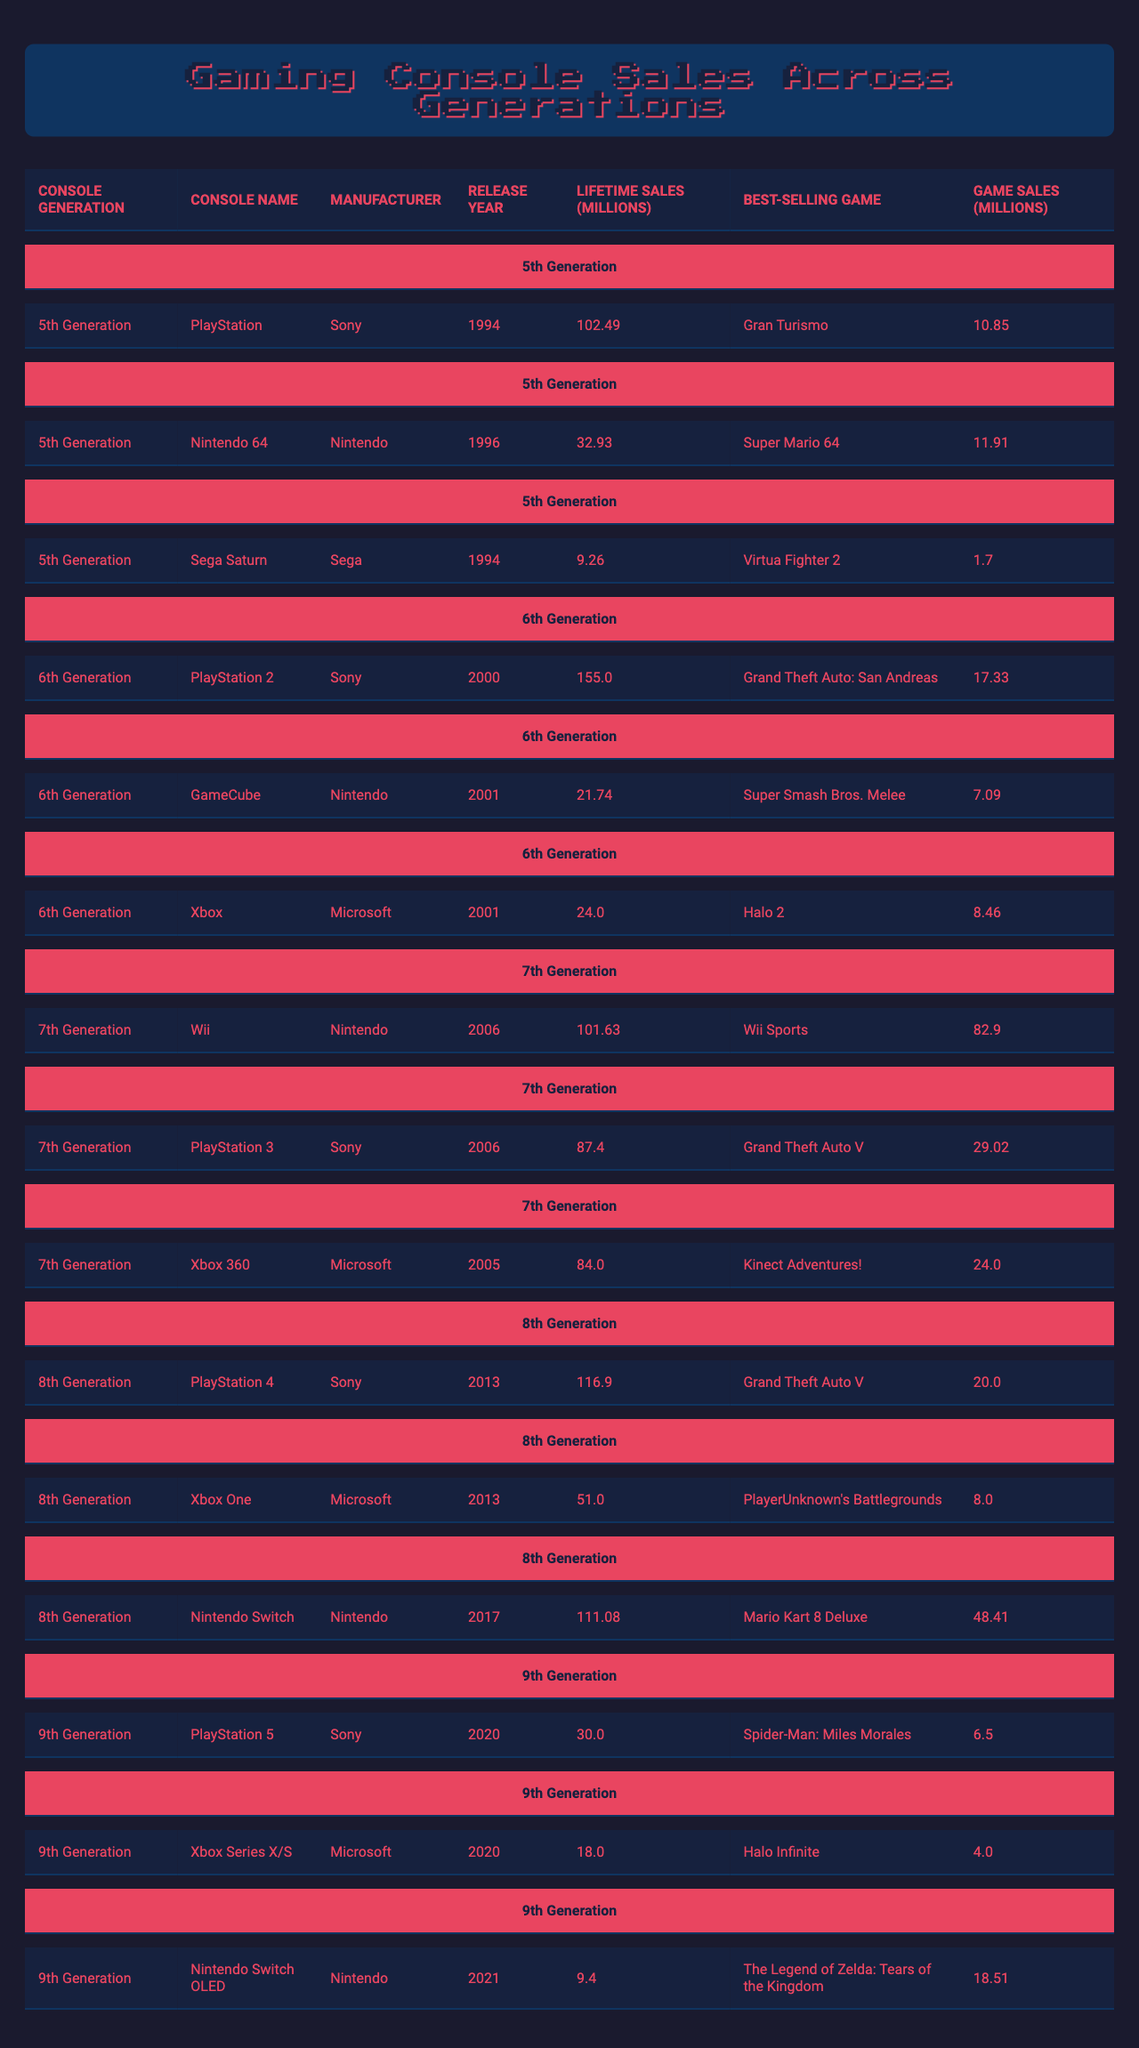What is the best-selling game on the PlayStation 2? According to the table, the best-selling game on the PlayStation 2 is "Grand Theft Auto: San Andreas."
Answer: Grand Theft Auto: San Andreas Which console has the highest lifetime sales? The table shows that the console with the highest lifetime sales is the PlayStation 2, with 155 million units sold.
Answer: PlayStation 2 What is the total lifetime sales for Nintendo consoles listed in the table? The lifetime sales for Nintendo consoles are: Nintendo 64 (32.93 million), GameCube (21.74 million), Wii (101.63 million), and Nintendo Switch (111.08 million). Adding these gives 32.93 + 21.74 + 101.63 + 111.08 = 267.38 million.
Answer: 267.38 million Is the Xbox Series X/S more successful in sales than the Nintendo Switch OLED? Comparing the lifetime sales, the Xbox Series X/S has 18 million units sold while the Nintendo Switch OLED has 9.4 million. Since 18 is greater than 9.4, the Xbox Series X/S is indeed more successful.
Answer: Yes What is the average lifetime sales of the consoles in the 7th generation? The 7th generation consoles listed are Wii (101.63 million), PlayStation 3 (87.4 million), and Xbox 360 (84 million). The total is 101.63 + 87.4 + 84 = 273.03 million. There are 3 consoles, so the average is 273.03 / 3 ≈ 91.01 million.
Answer: 91.01 million Which console was released first among the 6th generation? From the table, the PlayStation 2 was released first in 2000, while the GameCube and Xbox were both released in 2001.
Answer: PlayStation 2 What is the difference in lifetime sales between the PlayStation 4 and Xbox One? The lifetime sales for PlayStation 4 is 116.9 million, and for Xbox One, it is 51 million. Calculating the difference gives 116.9 - 51 = 65.9 million.
Answer: 65.9 million Which manufacturer has the most consoles in the top three lifetime sales? Reviewing the table, Sony's consoles are PlayStation, PlayStation 2, PlayStation 3, and PlayStation 4; Nintendo has the Nintendo 64, Wii, and Nintendo Switch. Sony has 4 consoles, and Nintendo has 3. Microsoft has 3 as well (Xbox, Xbox 360, Xbox One and Series X/S). Hence, Sony has the most consoles in the top three lifetime sales.
Answer: Sony Which console has the highest sales for a single game, and what is that game? The Wii has the highest sales for a single game with "Wii Sports," selling 82.9 million copies.
Answer: Wii Sports How many consoles had lifetime sales under 25 million? The Sega Saturn had 9.26 million, GameCube had 21.74 million, and Xbox had 24 million. Therefore, only the Sega Saturn is under 25 million.
Answer: 1 